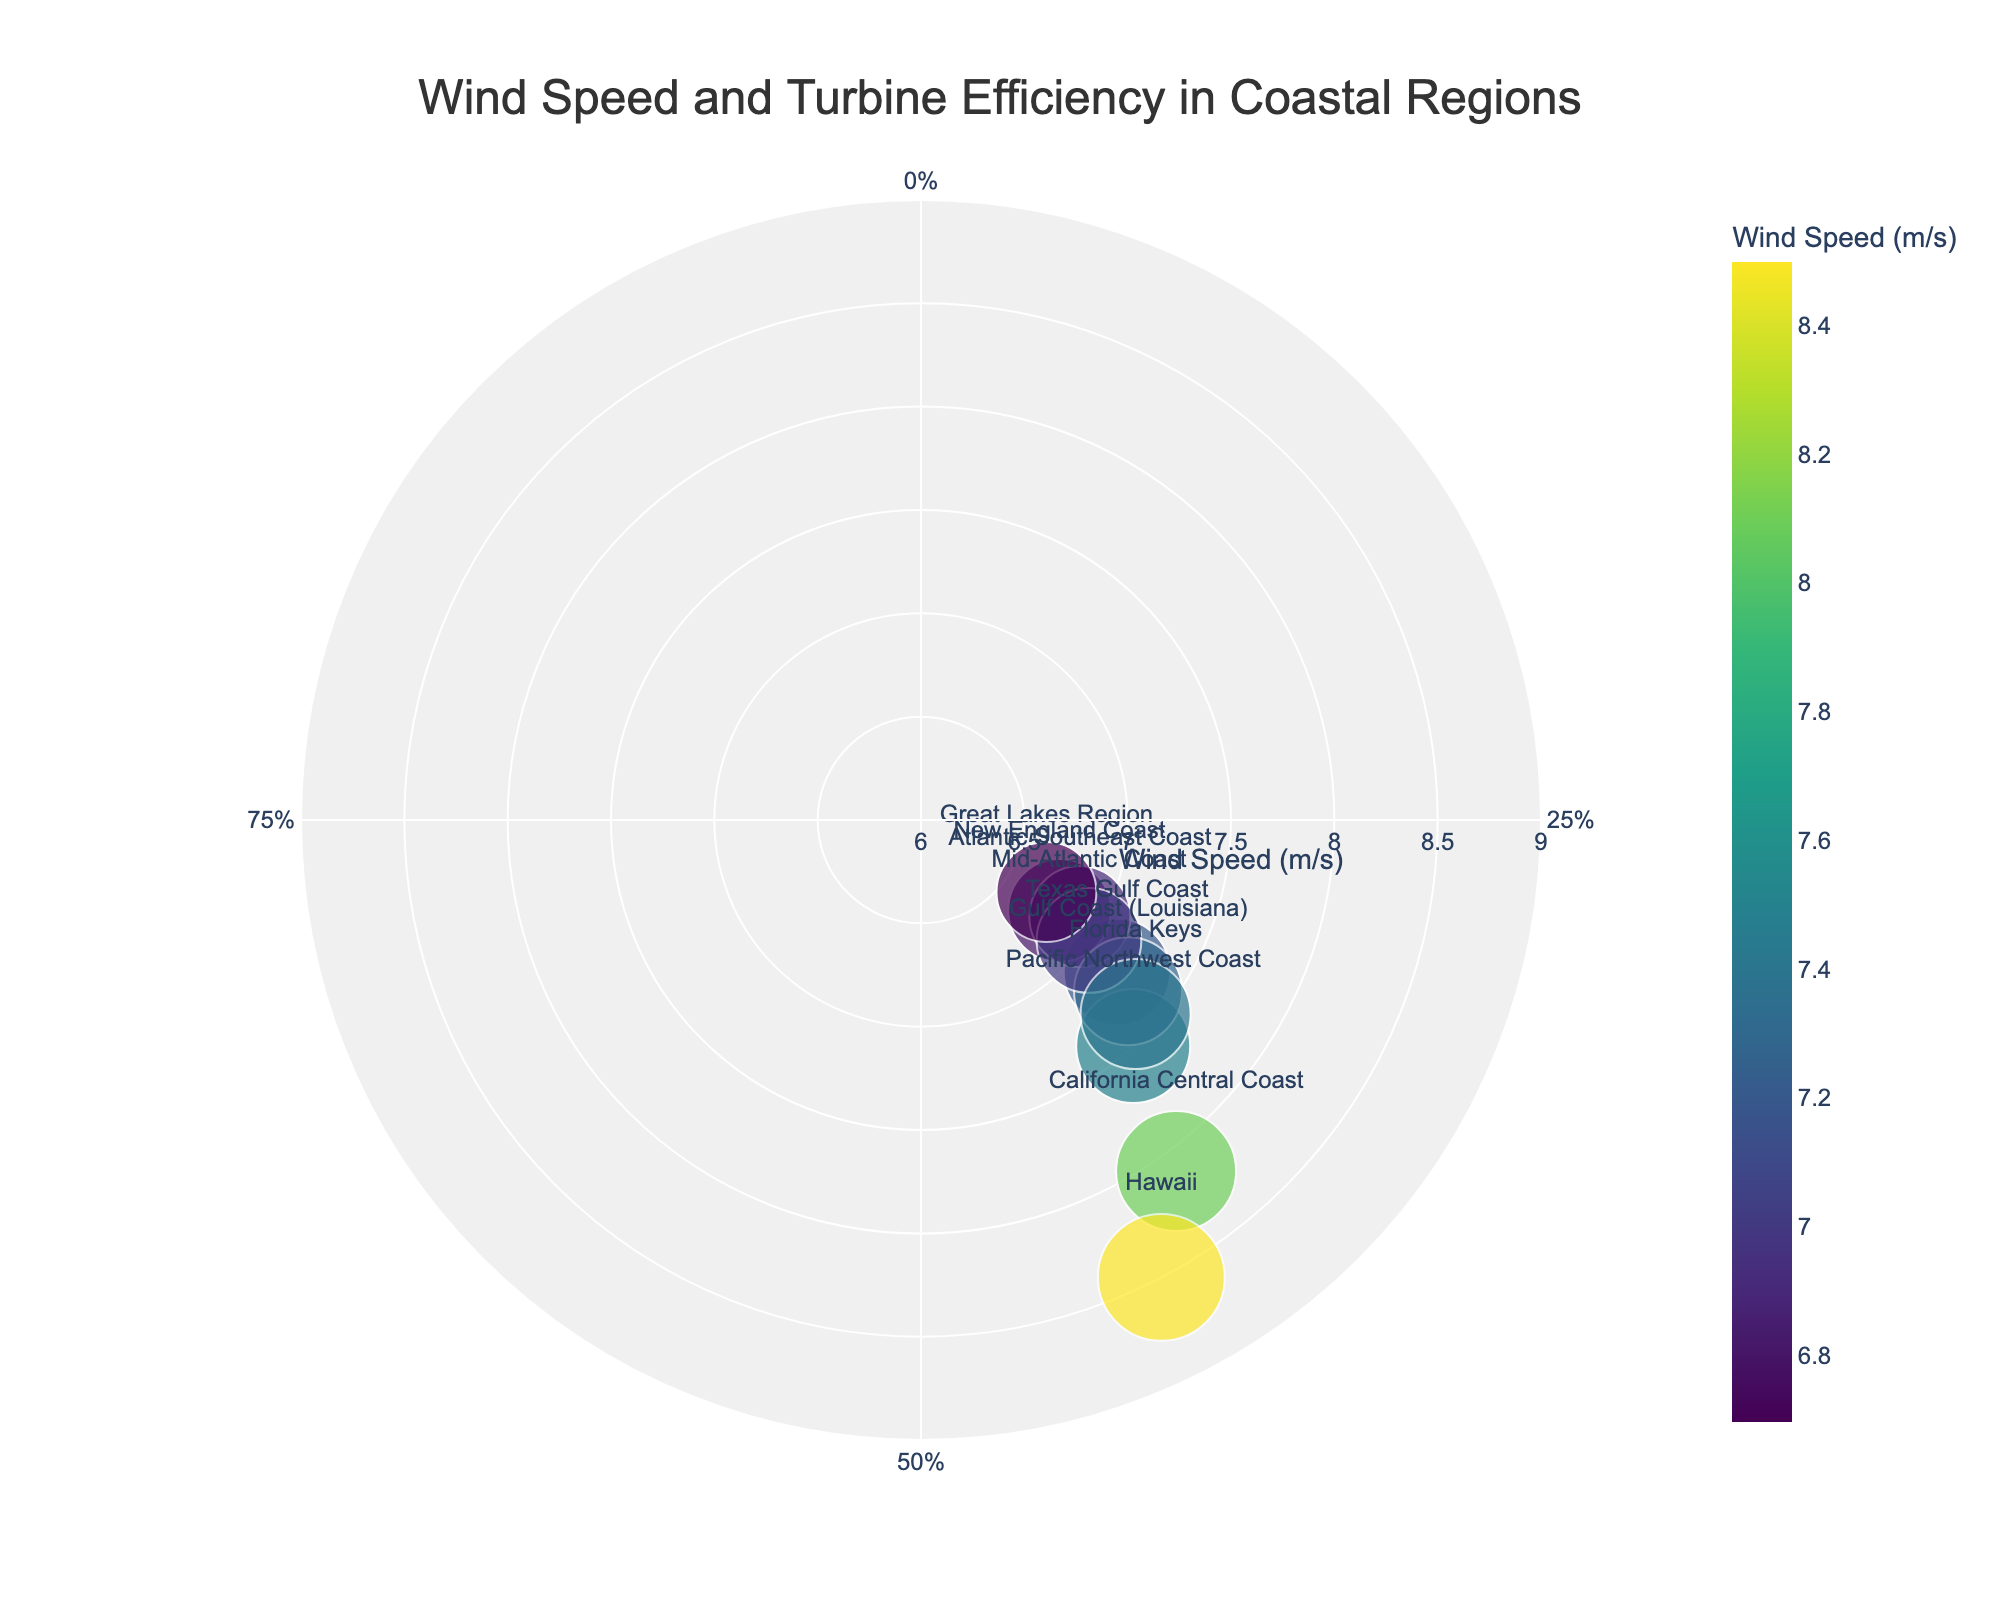What is the title of the chart? The title is located at the top center of the chart. It reads "Wind Speed and Turbine Efficiency in Coastal Regions".
Answer: Wind Speed and Turbine Efficiency in Coastal Regions How many regions are represented in the chart? Each marker corresponds to a coastal region. By counting all the markers, we find there are ten regions represented.
Answer: Ten Which region has the highest average wind speed? The wind speed values are shown on a color scale where the highest speed will be around the darkest color. Additionally, the Hawaii region, which is labeled, shows an average wind speed of 8.5 m/s.
Answer: Hawaii How is the wind speed represented visually? Wind speed is represented by the radial axis (distance from the center) and the color of the markers with a scale shown on the color bar.
Answer: Radial axis and color What is the relationship between average wind speed and turbine efficiency in the Hawaii region? By examining Hawaii in the chart, which is labeled, it has an average wind speed of 8.5 m/s and its efficiency is indicated around 42.3%.
Answer: 8.5 m/s and 42.3% Which region has the largest marker, and what does it indicate? The largest marker corresponds to the Hawaii region, indicating it has the highest turbine efficiency. Marker size represents turbine efficiency.
Answer: Hawaii, indicating high efficiency Between the Texas Gulf Coast and the California Central Coast, which region has a higher turbine efficiency? By comparing their respective positions on the angular axis, the California Central Coast shows a turbine efficiency closer to 40%, higher than Texas Gulf Coast's 35.5%.
Answer: California Central Coast Which region experiences a wind speed closest to 7 m/s, and what is its corresponding turbine efficiency? By locating the regions at the radial distance close to 7 m/s and checking their labels, the Mid-Atlantic Coast has a wind speed of 7.0 m/s and a turbine efficiency of 34.9%.
Answer: Mid-Atlantic Coast, 34.9% What is the difference in turbine efficiency between the New England Coast and the Gulf Coast (Louisiana)? The New England Coast has a turbine efficiency of 34.2%, while the Gulf Coast (Louisiana) has an efficiency of 36.0%. The difference is 36.0% - 34.2% = 1.8%.
Answer: 1.8% Does higher wind speed generally correlate with higher turbine efficiency in the coastal regions? By observing the overall trend in the plot, regions with higher wind speeds tend to have higher turbine efficiencies, as near the outer edge (higher wind speeds) markers are larger. There are exceptions, but the general trend supports the correlation.
Answer: Generally, yes 